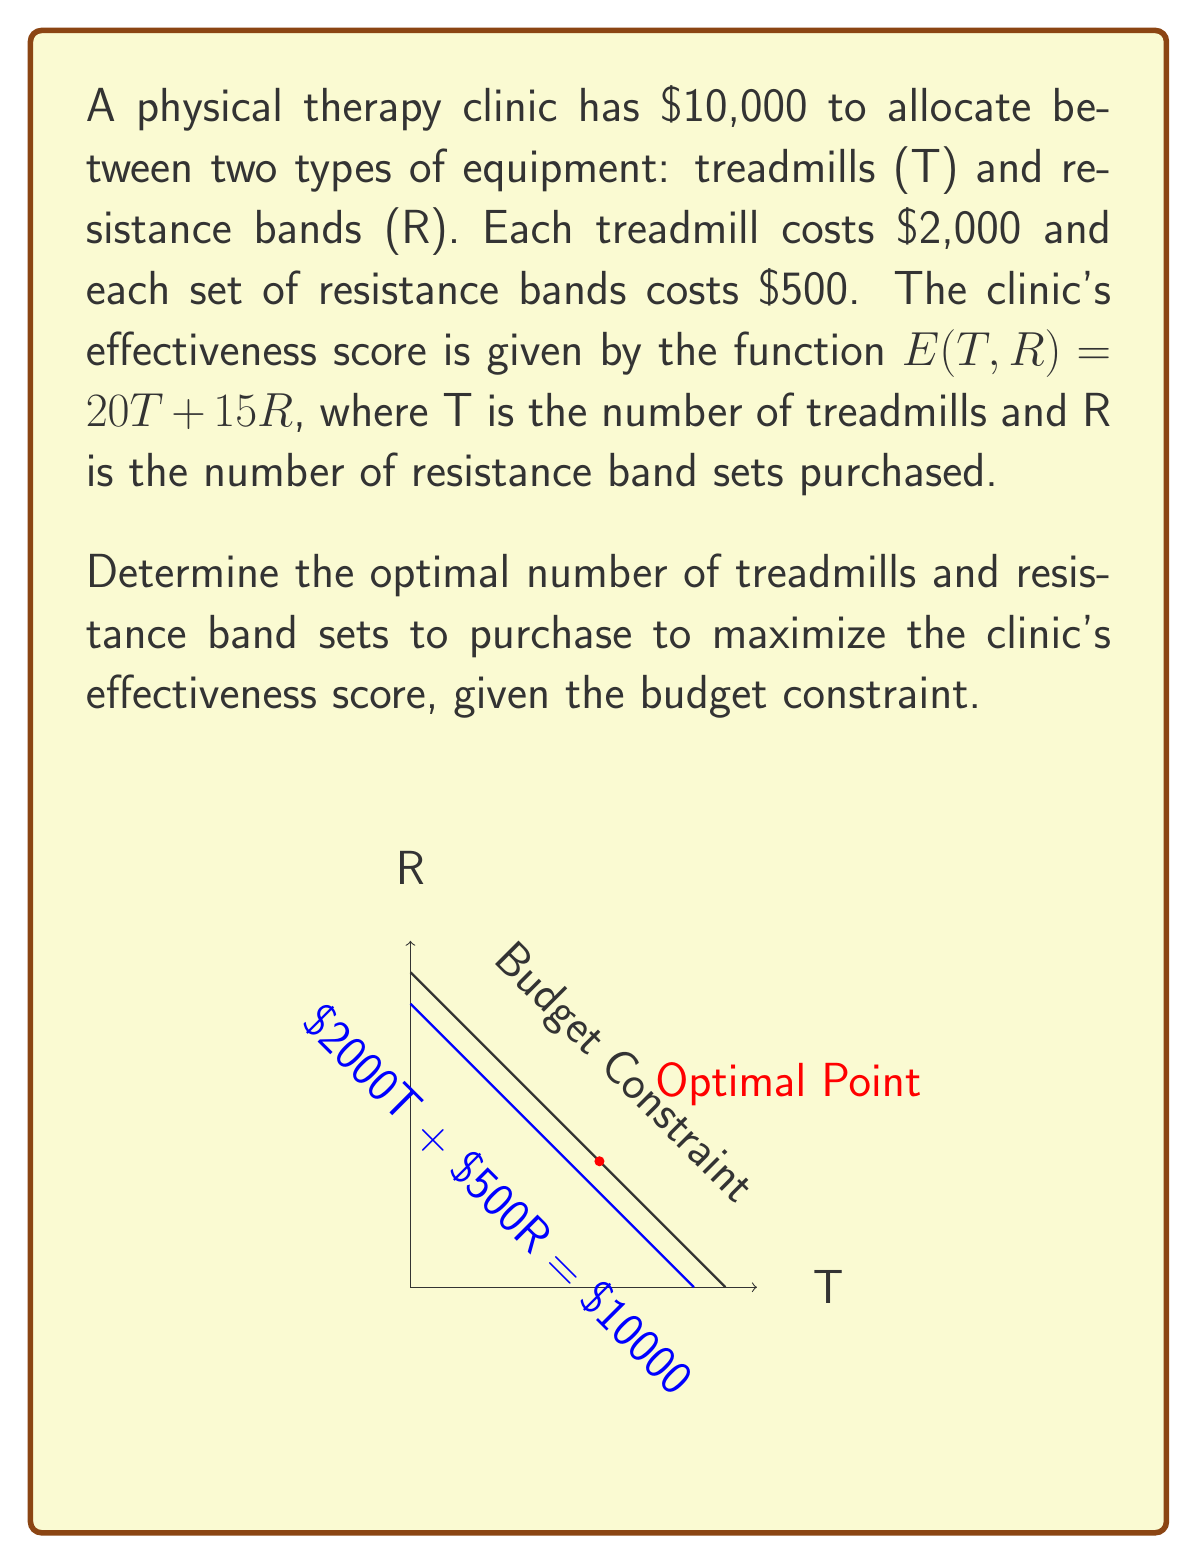Teach me how to tackle this problem. Let's approach this step-by-step using the principles of linear programming:

1) First, we need to set up our constraints:
   Budget constraint: $2000T + 500R \leq 10000$
   Non-negativity constraints: $T \geq 0, R \geq 0$

2) Our objective function is the effectiveness score:
   $E(T,R) = 20T + 15R$

3) To solve this, we can use the corner point method. The corner points of our feasible region are:
   (0,0), (5,0), (0,20), and the point where the budget constraint intersects the T and R axes.

4) Let's find this intersection point:
   When R = 0, T = 5
   When T = 0, R = 20

5) Now, we need to find the exact intersection point:
   $2000T + 500R = 10000$
   $4T + R = 20$

6) Solving these equations simultaneously:
   $R = 20 - 4T$
   Substituting into the effectiveness function:
   $E(T) = 20T + 15(20-4T) = 20T + 300 - 60T = 300 - 40T$

7) To maximize this, we take the derivative:
   $\frac{dE}{dT} = -40$

   This is always negative, meaning the maximum occurs at the smallest possible T value (within our constraints).

8) Therefore, the optimal solution is to spend all the budget on resistance bands:
   $R = 20, T = 0$

9) We can verify this by checking the effectiveness score at each corner point:
   (0,0): E = 0
   (5,0): E = 100
   (0,20): E = 300

Therefore, (0,20) gives the maximum effectiveness score.
Answer: 0 treadmills, 20 resistance band sets 